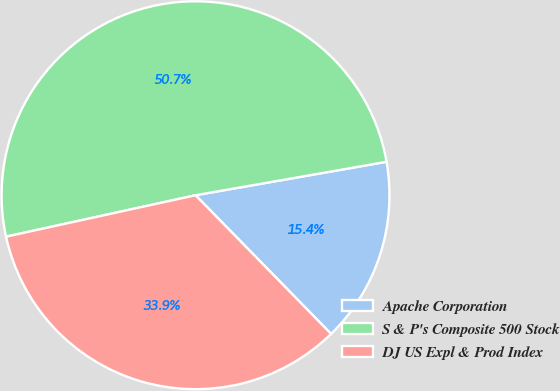Convert chart to OTSL. <chart><loc_0><loc_0><loc_500><loc_500><pie_chart><fcel>Apache Corporation<fcel>S & P's Composite 500 Stock<fcel>DJ US Expl & Prod Index<nl><fcel>15.44%<fcel>50.66%<fcel>33.89%<nl></chart> 